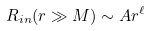Convert formula to latex. <formula><loc_0><loc_0><loc_500><loc_500>R _ { i n } ( r \gg M ) \sim A r ^ { \ell }</formula> 